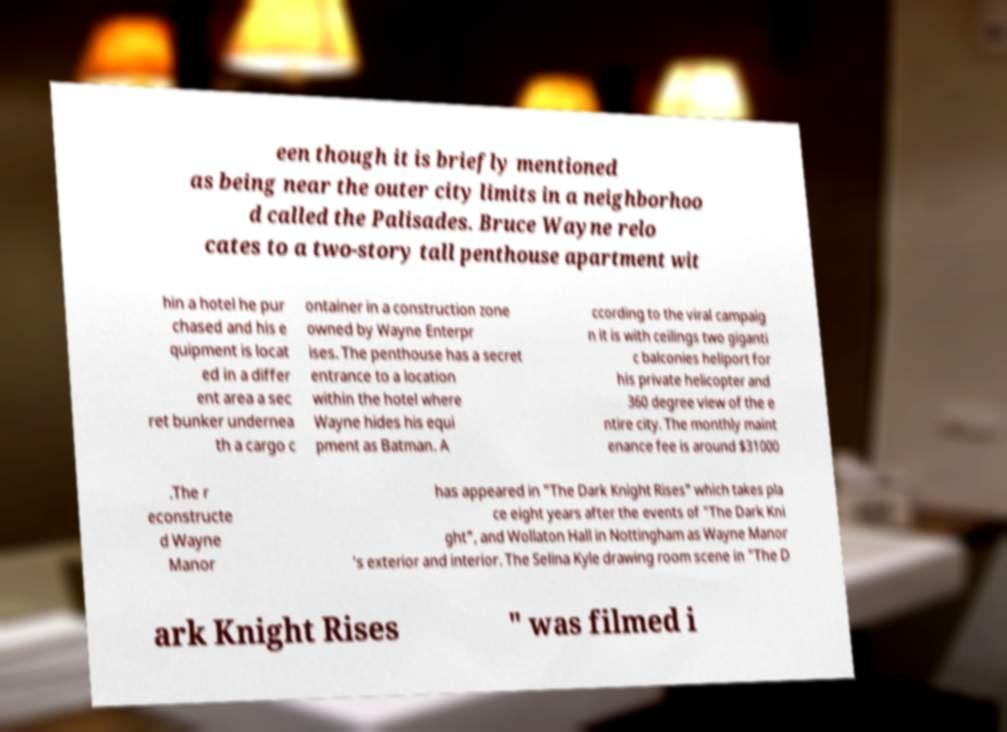Could you extract and type out the text from this image? een though it is briefly mentioned as being near the outer city limits in a neighborhoo d called the Palisades. Bruce Wayne relo cates to a two-story tall penthouse apartment wit hin a hotel he pur chased and his e quipment is locat ed in a differ ent area a sec ret bunker undernea th a cargo c ontainer in a construction zone owned by Wayne Enterpr ises. The penthouse has a secret entrance to a location within the hotel where Wayne hides his equi pment as Batman. A ccording to the viral campaig n it is with ceilings two giganti c balconies heliport for his private helicopter and 360 degree view of the e ntire city. The monthly maint enance fee is around $31000 .The r econstructe d Wayne Manor has appeared in "The Dark Knight Rises" which takes pla ce eight years after the events of "The Dark Kni ght", and Wollaton Hall in Nottingham as Wayne Manor 's exterior and interior. The Selina Kyle drawing room scene in "The D ark Knight Rises " was filmed i 